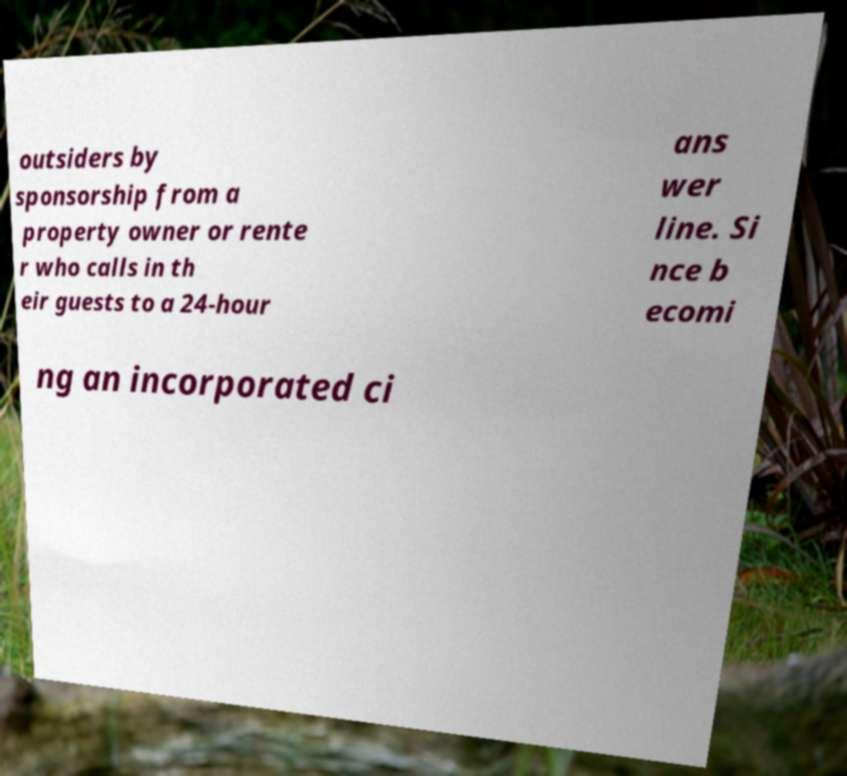Could you assist in decoding the text presented in this image and type it out clearly? outsiders by sponsorship from a property owner or rente r who calls in th eir guests to a 24-hour ans wer line. Si nce b ecomi ng an incorporated ci 